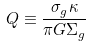Convert formula to latex. <formula><loc_0><loc_0><loc_500><loc_500>Q \equiv \frac { \sigma _ { g } \kappa } { \pi G \Sigma _ { g } }</formula> 